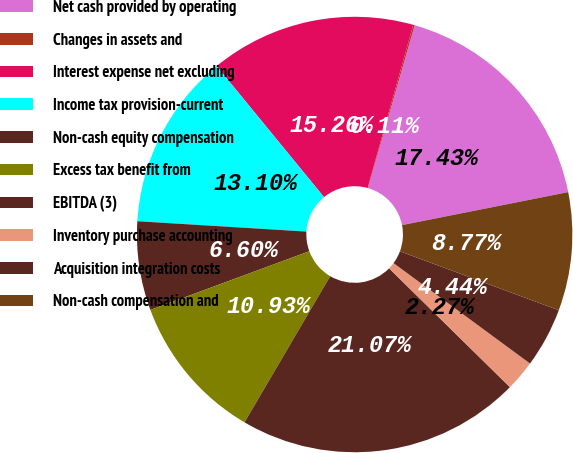Convert chart. <chart><loc_0><loc_0><loc_500><loc_500><pie_chart><fcel>Net cash provided by operating<fcel>Changes in assets and<fcel>Interest expense net excluding<fcel>Income tax provision-current<fcel>Non-cash equity compensation<fcel>Excess tax benefit from<fcel>EBITDA (3)<fcel>Inventory purchase accounting<fcel>Acquisition integration costs<fcel>Non-cash compensation and<nl><fcel>17.43%<fcel>0.11%<fcel>15.26%<fcel>13.1%<fcel>6.6%<fcel>10.93%<fcel>21.07%<fcel>2.27%<fcel>4.44%<fcel>8.77%<nl></chart> 